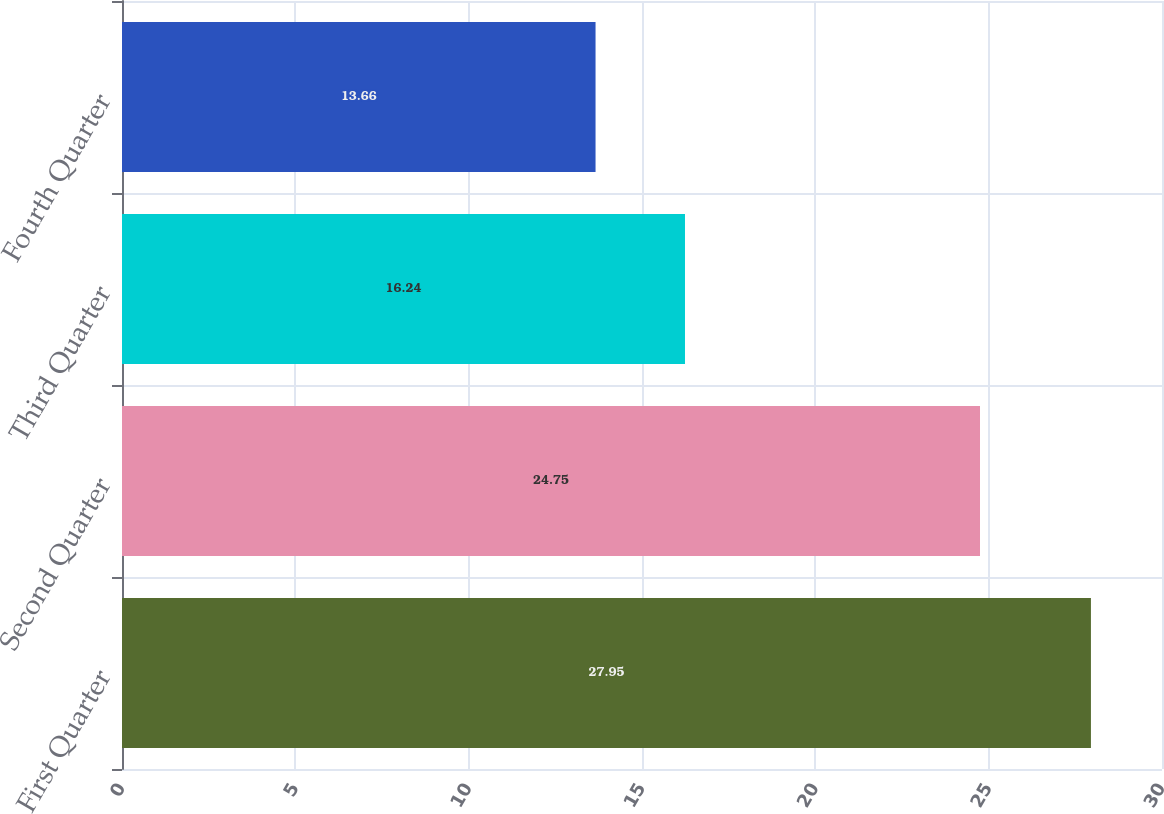Convert chart. <chart><loc_0><loc_0><loc_500><loc_500><bar_chart><fcel>First Quarter<fcel>Second Quarter<fcel>Third Quarter<fcel>Fourth Quarter<nl><fcel>27.95<fcel>24.75<fcel>16.24<fcel>13.66<nl></chart> 